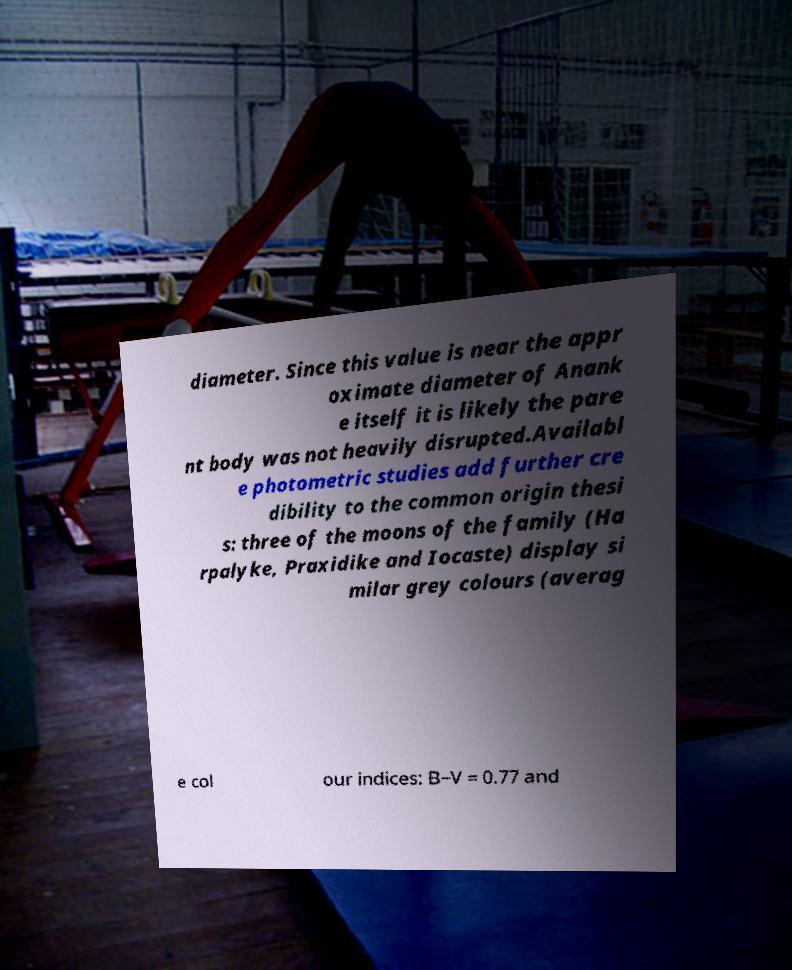Can you accurately transcribe the text from the provided image for me? diameter. Since this value is near the appr oximate diameter of Anank e itself it is likely the pare nt body was not heavily disrupted.Availabl e photometric studies add further cre dibility to the common origin thesi s: three of the moons of the family (Ha rpalyke, Praxidike and Iocaste) display si milar grey colours (averag e col our indices: B−V = 0.77 and 